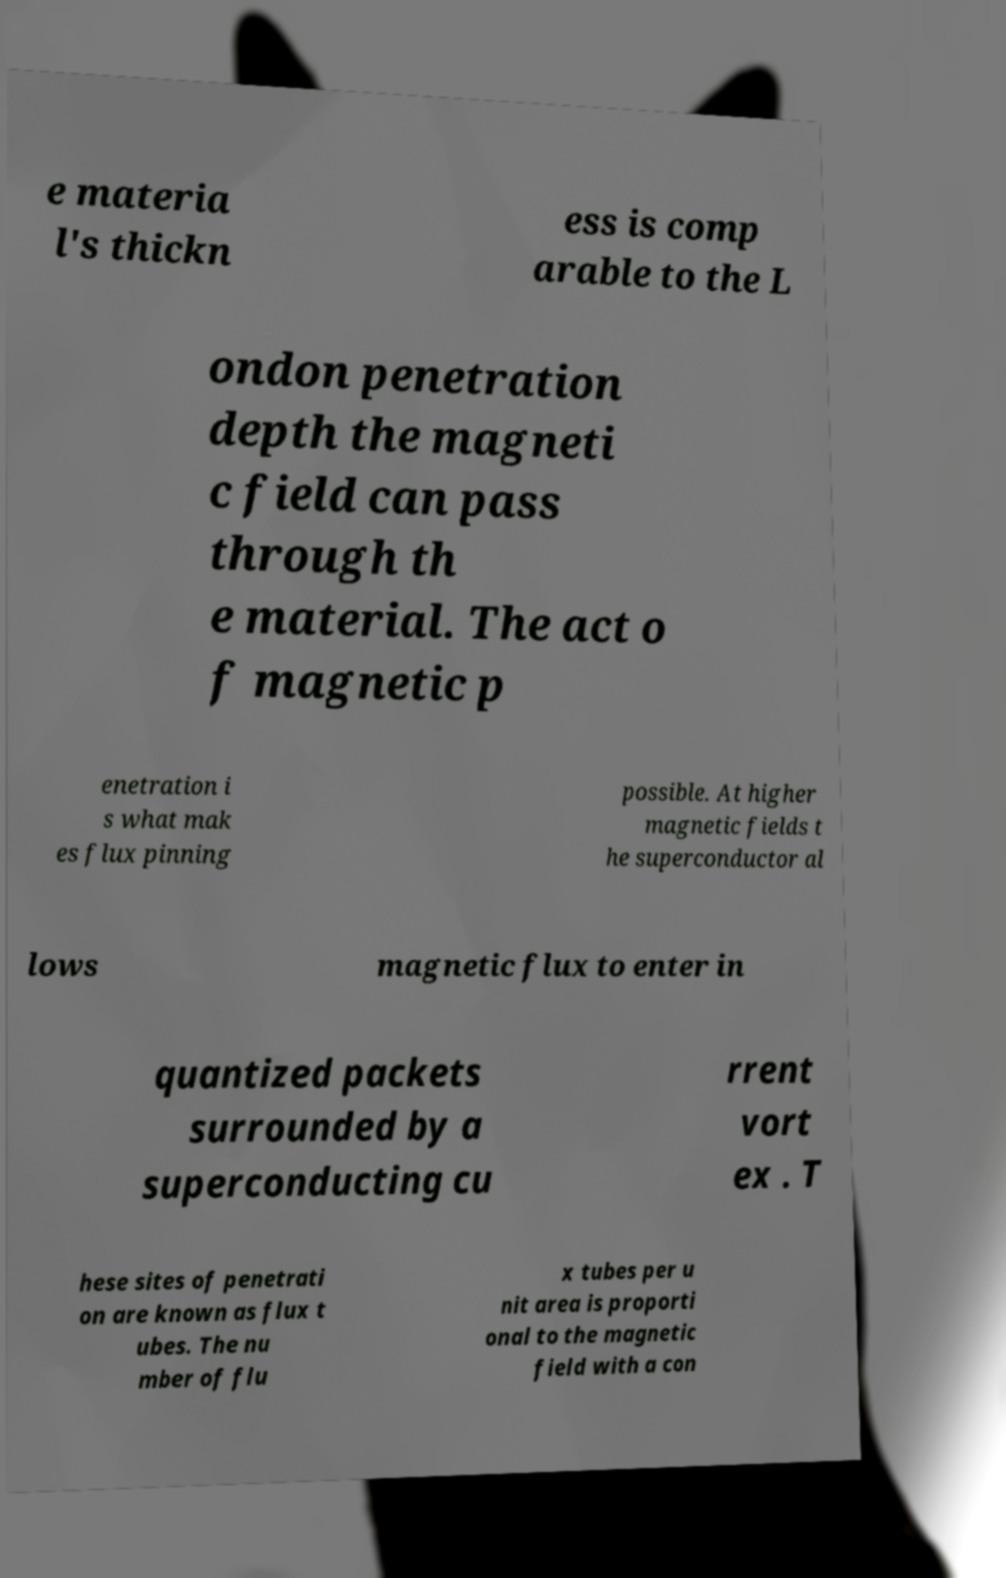What messages or text are displayed in this image? I need them in a readable, typed format. e materia l's thickn ess is comp arable to the L ondon penetration depth the magneti c field can pass through th e material. The act o f magnetic p enetration i s what mak es flux pinning possible. At higher magnetic fields t he superconductor al lows magnetic flux to enter in quantized packets surrounded by a superconducting cu rrent vort ex . T hese sites of penetrati on are known as flux t ubes. The nu mber of flu x tubes per u nit area is proporti onal to the magnetic field with a con 